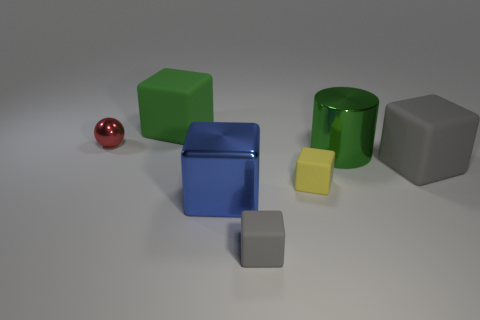Subtract all tiny yellow blocks. How many blocks are left? 4 Subtract all green blocks. How many blocks are left? 4 Subtract all spheres. How many objects are left? 6 Subtract 2 blocks. How many blocks are left? 3 Subtract all green cubes. Subtract all purple balls. How many cubes are left? 4 Subtract all purple cubes. How many purple spheres are left? 0 Subtract all cylinders. Subtract all small balls. How many objects are left? 5 Add 7 green metallic objects. How many green metallic objects are left? 8 Add 6 tiny objects. How many tiny objects exist? 9 Add 2 big matte objects. How many objects exist? 9 